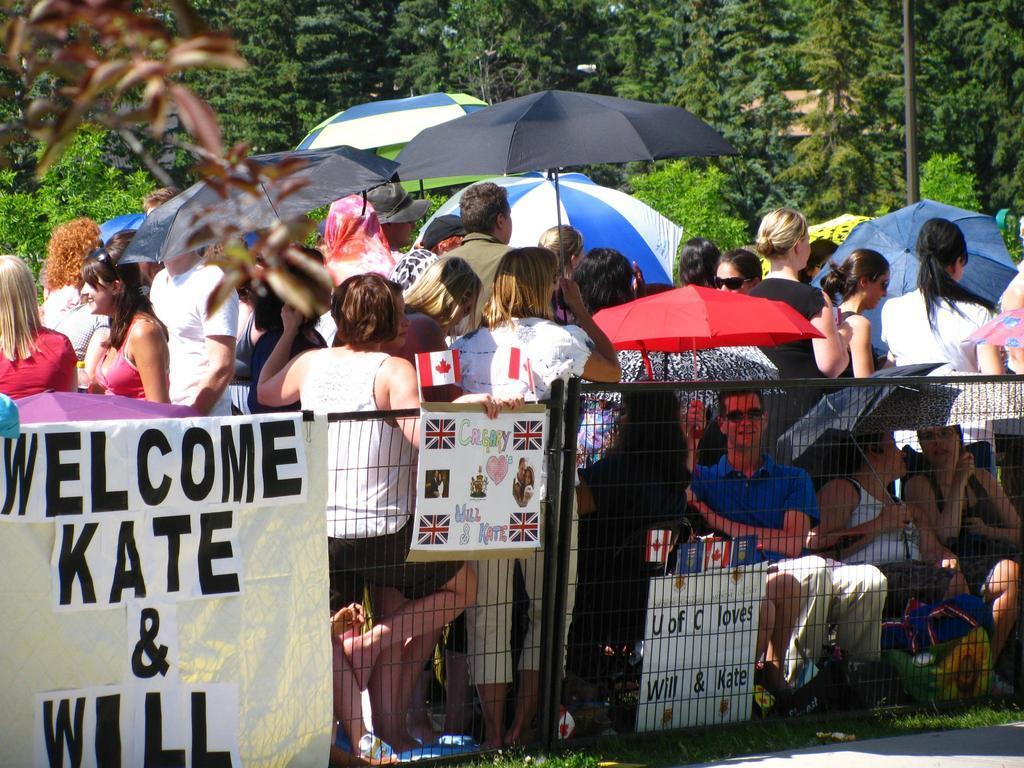Can you describe this image briefly? We can see banner and board on fence and we can see grass. Few people are sitting and these people are standing and we can see umbrellas. In the background we can see trees,rooftop and pole. 